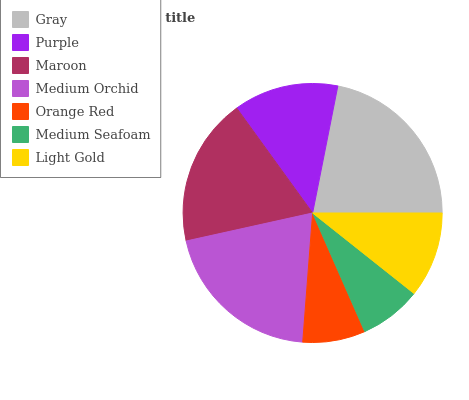Is Medium Seafoam the minimum?
Answer yes or no. Yes. Is Gray the maximum?
Answer yes or no. Yes. Is Purple the minimum?
Answer yes or no. No. Is Purple the maximum?
Answer yes or no. No. Is Gray greater than Purple?
Answer yes or no. Yes. Is Purple less than Gray?
Answer yes or no. Yes. Is Purple greater than Gray?
Answer yes or no. No. Is Gray less than Purple?
Answer yes or no. No. Is Purple the high median?
Answer yes or no. Yes. Is Purple the low median?
Answer yes or no. Yes. Is Gray the high median?
Answer yes or no. No. Is Medium Seafoam the low median?
Answer yes or no. No. 